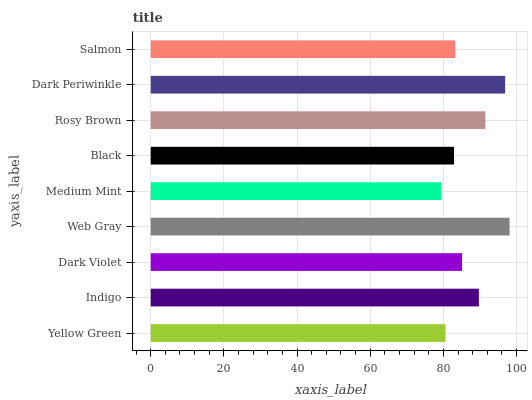Is Medium Mint the minimum?
Answer yes or no. Yes. Is Web Gray the maximum?
Answer yes or no. Yes. Is Indigo the minimum?
Answer yes or no. No. Is Indigo the maximum?
Answer yes or no. No. Is Indigo greater than Yellow Green?
Answer yes or no. Yes. Is Yellow Green less than Indigo?
Answer yes or no. Yes. Is Yellow Green greater than Indigo?
Answer yes or no. No. Is Indigo less than Yellow Green?
Answer yes or no. No. Is Dark Violet the high median?
Answer yes or no. Yes. Is Dark Violet the low median?
Answer yes or no. Yes. Is Indigo the high median?
Answer yes or no. No. Is Medium Mint the low median?
Answer yes or no. No. 